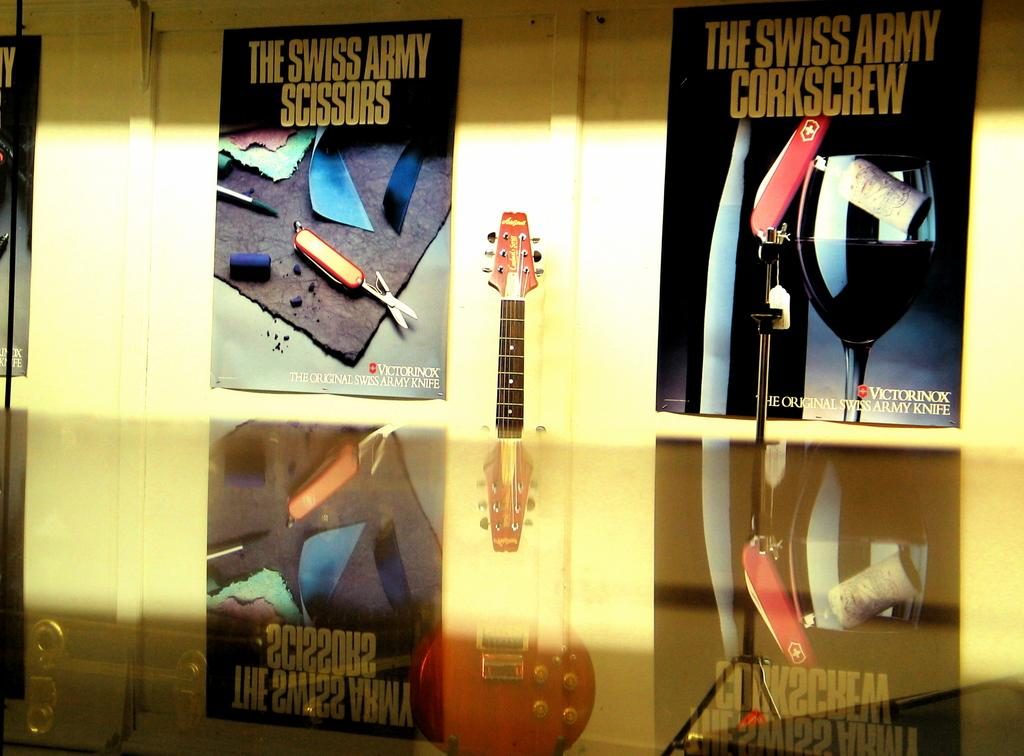<image>
Give a short and clear explanation of the subsequent image. Two posters for Swiss Army products with a guitar in between. 